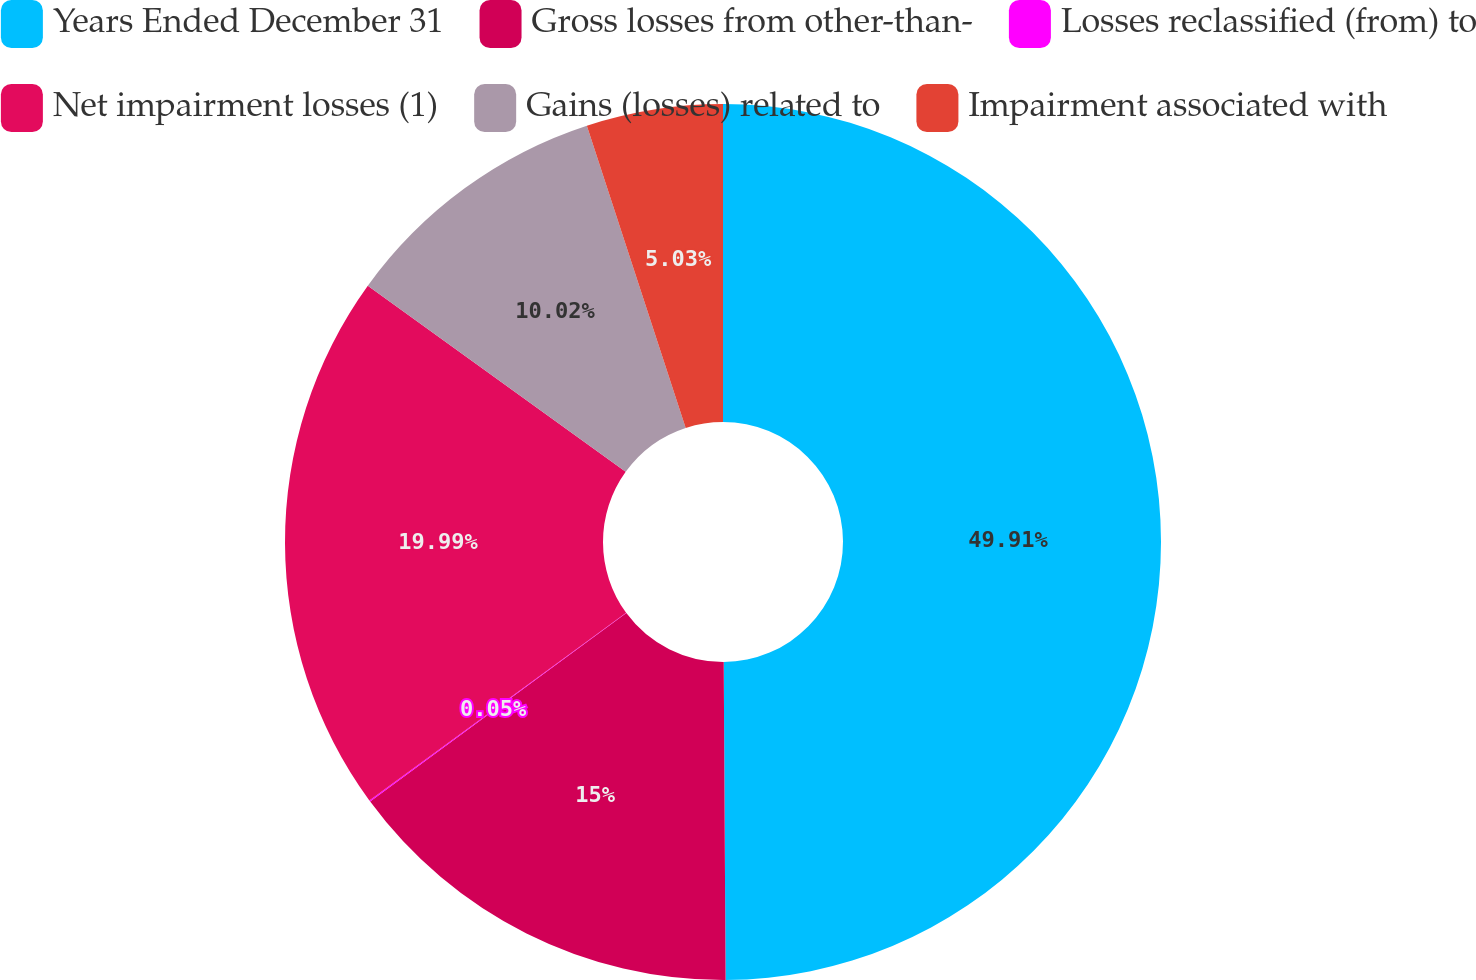Convert chart. <chart><loc_0><loc_0><loc_500><loc_500><pie_chart><fcel>Years Ended December 31<fcel>Gross losses from other-than-<fcel>Losses reclassified (from) to<fcel>Net impairment losses (1)<fcel>Gains (losses) related to<fcel>Impairment associated with<nl><fcel>49.9%<fcel>15.0%<fcel>0.05%<fcel>19.99%<fcel>10.02%<fcel>5.03%<nl></chart> 